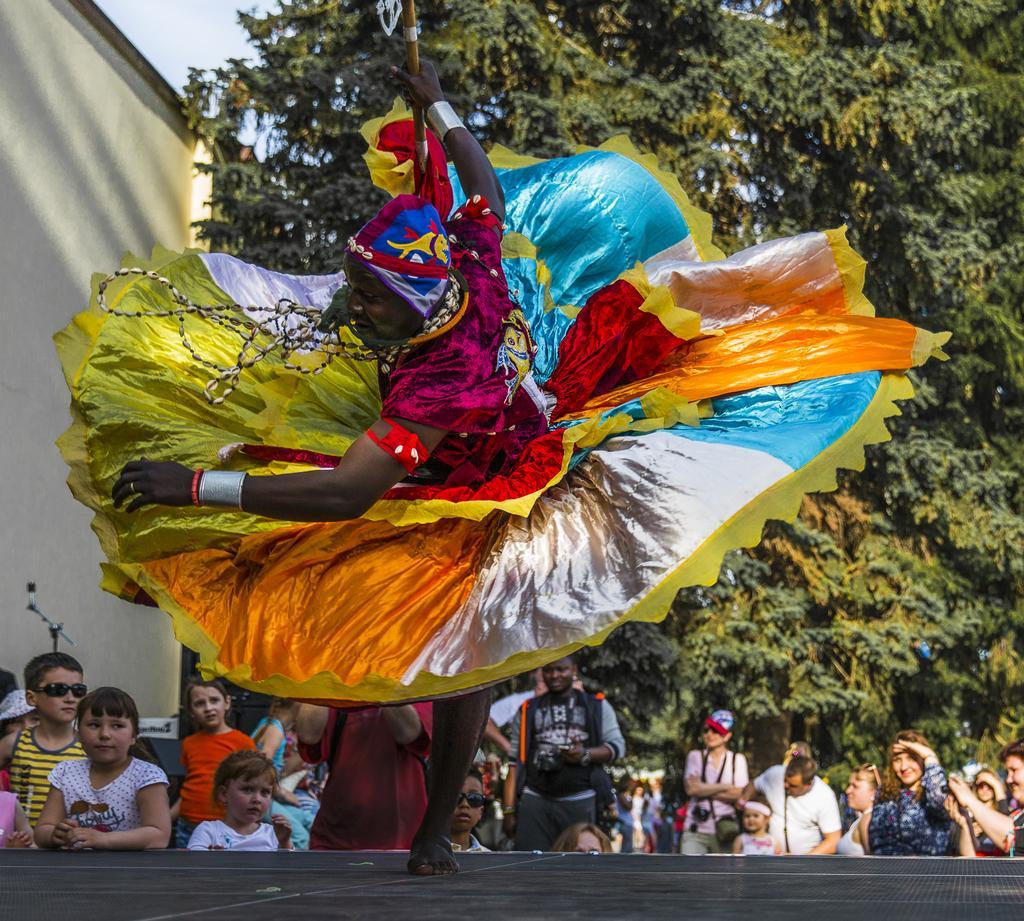Please provide a concise description of this image. In this image we can see a man wearing the fancy dress and holding the stick and performing on the stage. In the background we can see the kids and some persons. We can also see the trees. On the left we can see the building wall and also the mike. Sky is also visible. 